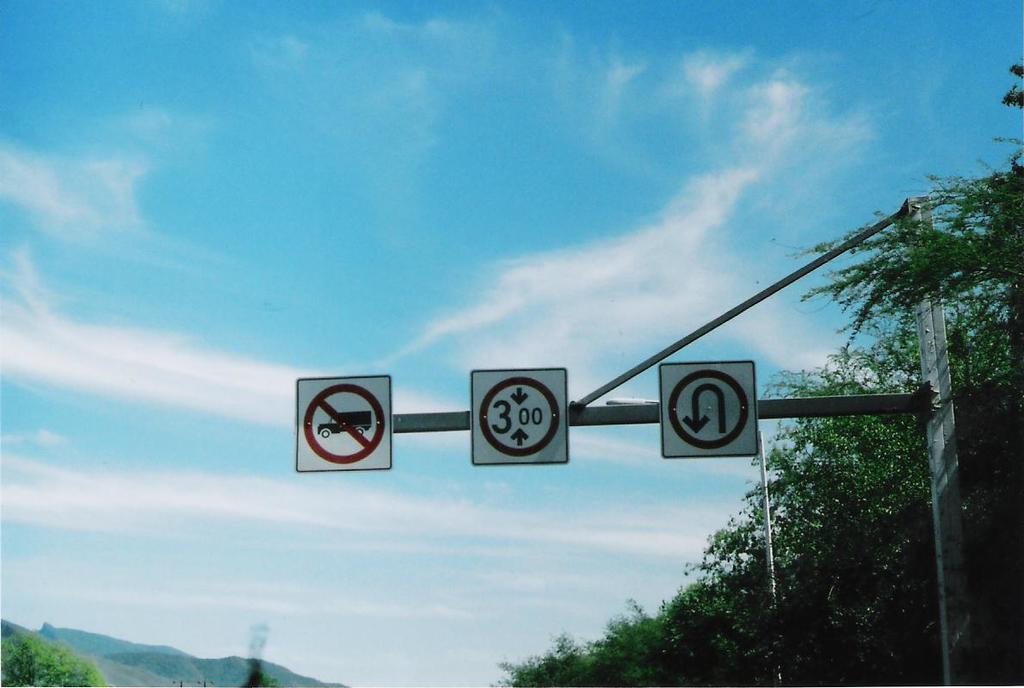<image>
Give a short and clear explanation of the subsequent image. A U turn is allowed on the street, but trucks are not allowed. 